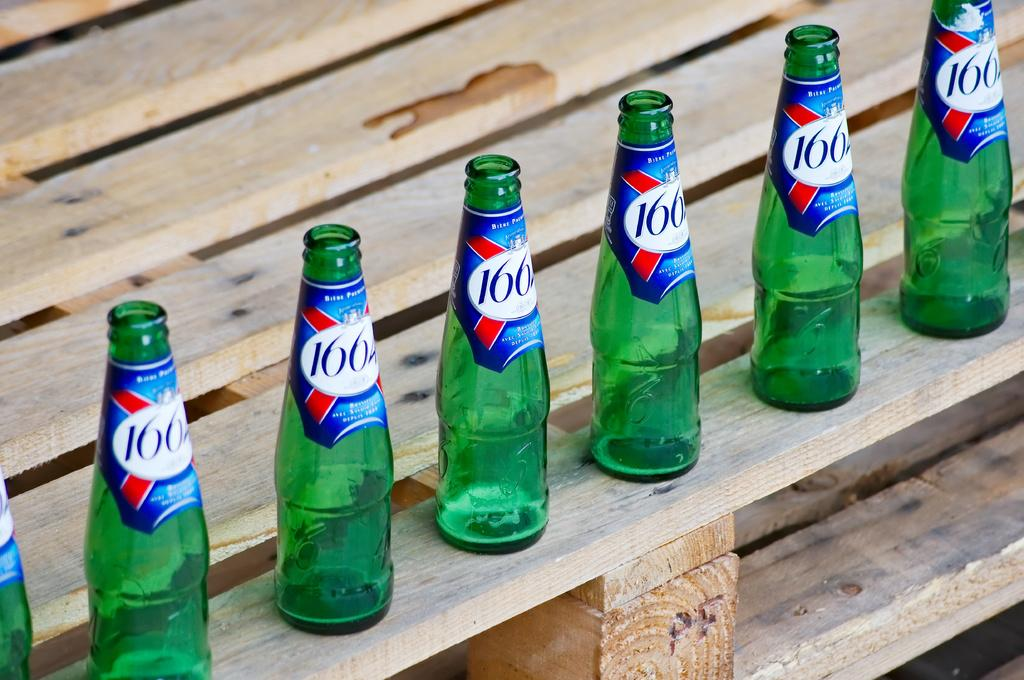<image>
Offer a succinct explanation of the picture presented. Several green 166 bottles are lined up on a wooden crate. 